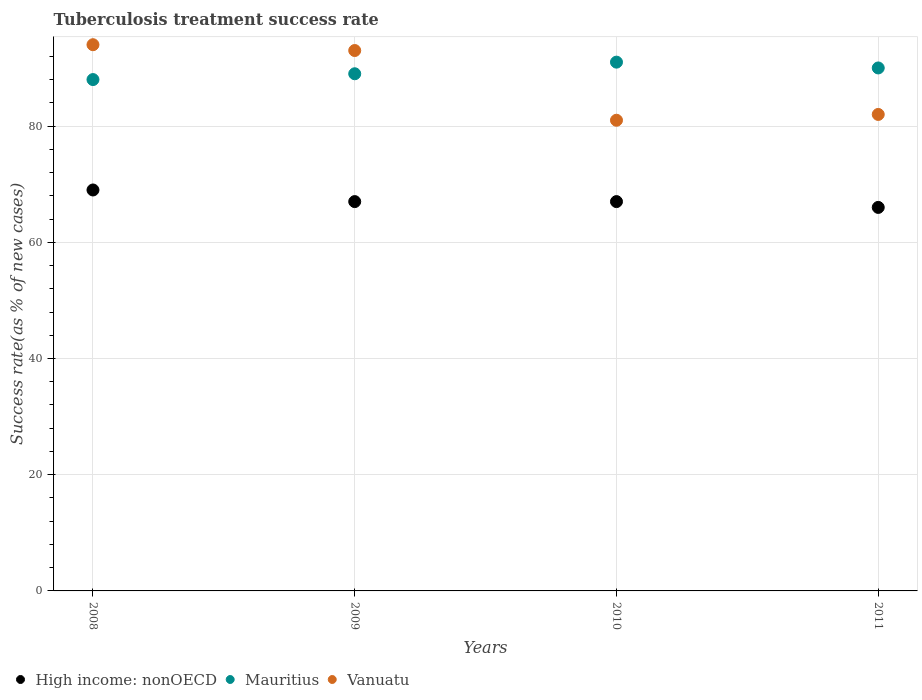How many different coloured dotlines are there?
Make the answer very short. 3. Is the number of dotlines equal to the number of legend labels?
Ensure brevity in your answer.  Yes. What is the tuberculosis treatment success rate in Vanuatu in 2011?
Make the answer very short. 82. Across all years, what is the maximum tuberculosis treatment success rate in Vanuatu?
Your response must be concise. 94. Across all years, what is the minimum tuberculosis treatment success rate in High income: nonOECD?
Offer a very short reply. 66. In which year was the tuberculosis treatment success rate in Vanuatu minimum?
Your answer should be compact. 2010. What is the total tuberculosis treatment success rate in Mauritius in the graph?
Provide a succinct answer. 358. What is the difference between the tuberculosis treatment success rate in Vanuatu in 2011 and the tuberculosis treatment success rate in Mauritius in 2009?
Make the answer very short. -7. What is the average tuberculosis treatment success rate in High income: nonOECD per year?
Offer a terse response. 67.25. In the year 2011, what is the difference between the tuberculosis treatment success rate in Mauritius and tuberculosis treatment success rate in High income: nonOECD?
Your answer should be compact. 24. In how many years, is the tuberculosis treatment success rate in Mauritius greater than 28 %?
Ensure brevity in your answer.  4. What is the ratio of the tuberculosis treatment success rate in Vanuatu in 2009 to that in 2010?
Your answer should be very brief. 1.15. Is the tuberculosis treatment success rate in Mauritius in 2008 less than that in 2011?
Make the answer very short. Yes. What is the difference between the highest and the second highest tuberculosis treatment success rate in High income: nonOECD?
Ensure brevity in your answer.  2. What is the difference between the highest and the lowest tuberculosis treatment success rate in Vanuatu?
Your answer should be very brief. 13. Is the sum of the tuberculosis treatment success rate in High income: nonOECD in 2008 and 2011 greater than the maximum tuberculosis treatment success rate in Vanuatu across all years?
Offer a very short reply. Yes. Is it the case that in every year, the sum of the tuberculosis treatment success rate in Vanuatu and tuberculosis treatment success rate in Mauritius  is greater than the tuberculosis treatment success rate in High income: nonOECD?
Your answer should be very brief. Yes. Does the tuberculosis treatment success rate in Vanuatu monotonically increase over the years?
Keep it short and to the point. No. How many dotlines are there?
Your answer should be very brief. 3. What is the difference between two consecutive major ticks on the Y-axis?
Offer a terse response. 20. Does the graph contain any zero values?
Give a very brief answer. No. Where does the legend appear in the graph?
Provide a short and direct response. Bottom left. How are the legend labels stacked?
Your response must be concise. Horizontal. What is the title of the graph?
Your answer should be compact. Tuberculosis treatment success rate. Does "China" appear as one of the legend labels in the graph?
Your answer should be very brief. No. What is the label or title of the Y-axis?
Give a very brief answer. Success rate(as % of new cases). What is the Success rate(as % of new cases) in High income: nonOECD in 2008?
Offer a very short reply. 69. What is the Success rate(as % of new cases) of Mauritius in 2008?
Offer a very short reply. 88. What is the Success rate(as % of new cases) of Vanuatu in 2008?
Your answer should be compact. 94. What is the Success rate(as % of new cases) in Mauritius in 2009?
Keep it short and to the point. 89. What is the Success rate(as % of new cases) in Vanuatu in 2009?
Your answer should be compact. 93. What is the Success rate(as % of new cases) in High income: nonOECD in 2010?
Give a very brief answer. 67. What is the Success rate(as % of new cases) in Mauritius in 2010?
Provide a succinct answer. 91. What is the Success rate(as % of new cases) of Vanuatu in 2010?
Ensure brevity in your answer.  81. What is the Success rate(as % of new cases) of High income: nonOECD in 2011?
Your answer should be compact. 66. What is the Success rate(as % of new cases) in Mauritius in 2011?
Ensure brevity in your answer.  90. What is the Success rate(as % of new cases) of Vanuatu in 2011?
Offer a terse response. 82. Across all years, what is the maximum Success rate(as % of new cases) of Mauritius?
Offer a very short reply. 91. Across all years, what is the maximum Success rate(as % of new cases) of Vanuatu?
Your answer should be compact. 94. Across all years, what is the minimum Success rate(as % of new cases) of High income: nonOECD?
Your answer should be compact. 66. Across all years, what is the minimum Success rate(as % of new cases) in Mauritius?
Give a very brief answer. 88. Across all years, what is the minimum Success rate(as % of new cases) of Vanuatu?
Keep it short and to the point. 81. What is the total Success rate(as % of new cases) of High income: nonOECD in the graph?
Your response must be concise. 269. What is the total Success rate(as % of new cases) of Mauritius in the graph?
Offer a very short reply. 358. What is the total Success rate(as % of new cases) in Vanuatu in the graph?
Your answer should be compact. 350. What is the difference between the Success rate(as % of new cases) in Vanuatu in 2008 and that in 2009?
Make the answer very short. 1. What is the difference between the Success rate(as % of new cases) in Vanuatu in 2008 and that in 2010?
Offer a terse response. 13. What is the difference between the Success rate(as % of new cases) of High income: nonOECD in 2008 and that in 2011?
Your answer should be compact. 3. What is the difference between the Success rate(as % of new cases) in Vanuatu in 2008 and that in 2011?
Your response must be concise. 12. What is the difference between the Success rate(as % of new cases) of High income: nonOECD in 2009 and that in 2010?
Offer a terse response. 0. What is the difference between the Success rate(as % of new cases) in Mauritius in 2009 and that in 2010?
Your answer should be very brief. -2. What is the difference between the Success rate(as % of new cases) of High income: nonOECD in 2009 and that in 2011?
Provide a short and direct response. 1. What is the difference between the Success rate(as % of new cases) of Vanuatu in 2009 and that in 2011?
Ensure brevity in your answer.  11. What is the difference between the Success rate(as % of new cases) in High income: nonOECD in 2010 and that in 2011?
Offer a very short reply. 1. What is the difference between the Success rate(as % of new cases) in Vanuatu in 2010 and that in 2011?
Make the answer very short. -1. What is the difference between the Success rate(as % of new cases) of Mauritius in 2008 and the Success rate(as % of new cases) of Vanuatu in 2009?
Offer a terse response. -5. What is the difference between the Success rate(as % of new cases) in High income: nonOECD in 2008 and the Success rate(as % of new cases) in Vanuatu in 2010?
Offer a terse response. -12. What is the difference between the Success rate(as % of new cases) of Mauritius in 2008 and the Success rate(as % of new cases) of Vanuatu in 2010?
Your answer should be compact. 7. What is the difference between the Success rate(as % of new cases) of High income: nonOECD in 2008 and the Success rate(as % of new cases) of Mauritius in 2011?
Offer a terse response. -21. What is the difference between the Success rate(as % of new cases) of High income: nonOECD in 2008 and the Success rate(as % of new cases) of Vanuatu in 2011?
Offer a terse response. -13. What is the difference between the Success rate(as % of new cases) of High income: nonOECD in 2009 and the Success rate(as % of new cases) of Mauritius in 2010?
Provide a succinct answer. -24. What is the difference between the Success rate(as % of new cases) in Mauritius in 2009 and the Success rate(as % of new cases) in Vanuatu in 2010?
Keep it short and to the point. 8. What is the difference between the Success rate(as % of new cases) of High income: nonOECD in 2009 and the Success rate(as % of new cases) of Mauritius in 2011?
Your response must be concise. -23. What is the difference between the Success rate(as % of new cases) of High income: nonOECD in 2009 and the Success rate(as % of new cases) of Vanuatu in 2011?
Your answer should be compact. -15. What is the difference between the Success rate(as % of new cases) of Mauritius in 2010 and the Success rate(as % of new cases) of Vanuatu in 2011?
Provide a succinct answer. 9. What is the average Success rate(as % of new cases) of High income: nonOECD per year?
Ensure brevity in your answer.  67.25. What is the average Success rate(as % of new cases) of Mauritius per year?
Offer a terse response. 89.5. What is the average Success rate(as % of new cases) in Vanuatu per year?
Provide a succinct answer. 87.5. In the year 2008, what is the difference between the Success rate(as % of new cases) of High income: nonOECD and Success rate(as % of new cases) of Mauritius?
Offer a very short reply. -19. In the year 2008, what is the difference between the Success rate(as % of new cases) of Mauritius and Success rate(as % of new cases) of Vanuatu?
Ensure brevity in your answer.  -6. In the year 2009, what is the difference between the Success rate(as % of new cases) in High income: nonOECD and Success rate(as % of new cases) in Mauritius?
Offer a terse response. -22. In the year 2009, what is the difference between the Success rate(as % of new cases) in Mauritius and Success rate(as % of new cases) in Vanuatu?
Offer a terse response. -4. In the year 2010, what is the difference between the Success rate(as % of new cases) in Mauritius and Success rate(as % of new cases) in Vanuatu?
Give a very brief answer. 10. In the year 2011, what is the difference between the Success rate(as % of new cases) in High income: nonOECD and Success rate(as % of new cases) in Mauritius?
Your answer should be compact. -24. In the year 2011, what is the difference between the Success rate(as % of new cases) in High income: nonOECD and Success rate(as % of new cases) in Vanuatu?
Provide a succinct answer. -16. In the year 2011, what is the difference between the Success rate(as % of new cases) of Mauritius and Success rate(as % of new cases) of Vanuatu?
Ensure brevity in your answer.  8. What is the ratio of the Success rate(as % of new cases) in High income: nonOECD in 2008 to that in 2009?
Keep it short and to the point. 1.03. What is the ratio of the Success rate(as % of new cases) in Mauritius in 2008 to that in 2009?
Your answer should be very brief. 0.99. What is the ratio of the Success rate(as % of new cases) of Vanuatu in 2008 to that in 2009?
Provide a short and direct response. 1.01. What is the ratio of the Success rate(as % of new cases) of High income: nonOECD in 2008 to that in 2010?
Ensure brevity in your answer.  1.03. What is the ratio of the Success rate(as % of new cases) in Mauritius in 2008 to that in 2010?
Your answer should be compact. 0.97. What is the ratio of the Success rate(as % of new cases) of Vanuatu in 2008 to that in 2010?
Provide a short and direct response. 1.16. What is the ratio of the Success rate(as % of new cases) in High income: nonOECD in 2008 to that in 2011?
Give a very brief answer. 1.05. What is the ratio of the Success rate(as % of new cases) in Mauritius in 2008 to that in 2011?
Make the answer very short. 0.98. What is the ratio of the Success rate(as % of new cases) of Vanuatu in 2008 to that in 2011?
Offer a terse response. 1.15. What is the ratio of the Success rate(as % of new cases) of High income: nonOECD in 2009 to that in 2010?
Offer a terse response. 1. What is the ratio of the Success rate(as % of new cases) of Vanuatu in 2009 to that in 2010?
Your answer should be compact. 1.15. What is the ratio of the Success rate(as % of new cases) of High income: nonOECD in 2009 to that in 2011?
Provide a short and direct response. 1.02. What is the ratio of the Success rate(as % of new cases) in Mauritius in 2009 to that in 2011?
Keep it short and to the point. 0.99. What is the ratio of the Success rate(as % of new cases) of Vanuatu in 2009 to that in 2011?
Make the answer very short. 1.13. What is the ratio of the Success rate(as % of new cases) in High income: nonOECD in 2010 to that in 2011?
Keep it short and to the point. 1.02. What is the ratio of the Success rate(as % of new cases) in Mauritius in 2010 to that in 2011?
Your answer should be very brief. 1.01. What is the difference between the highest and the second highest Success rate(as % of new cases) in Mauritius?
Offer a very short reply. 1. What is the difference between the highest and the second highest Success rate(as % of new cases) in Vanuatu?
Offer a terse response. 1. What is the difference between the highest and the lowest Success rate(as % of new cases) in High income: nonOECD?
Provide a short and direct response. 3. What is the difference between the highest and the lowest Success rate(as % of new cases) of Mauritius?
Your response must be concise. 3. 